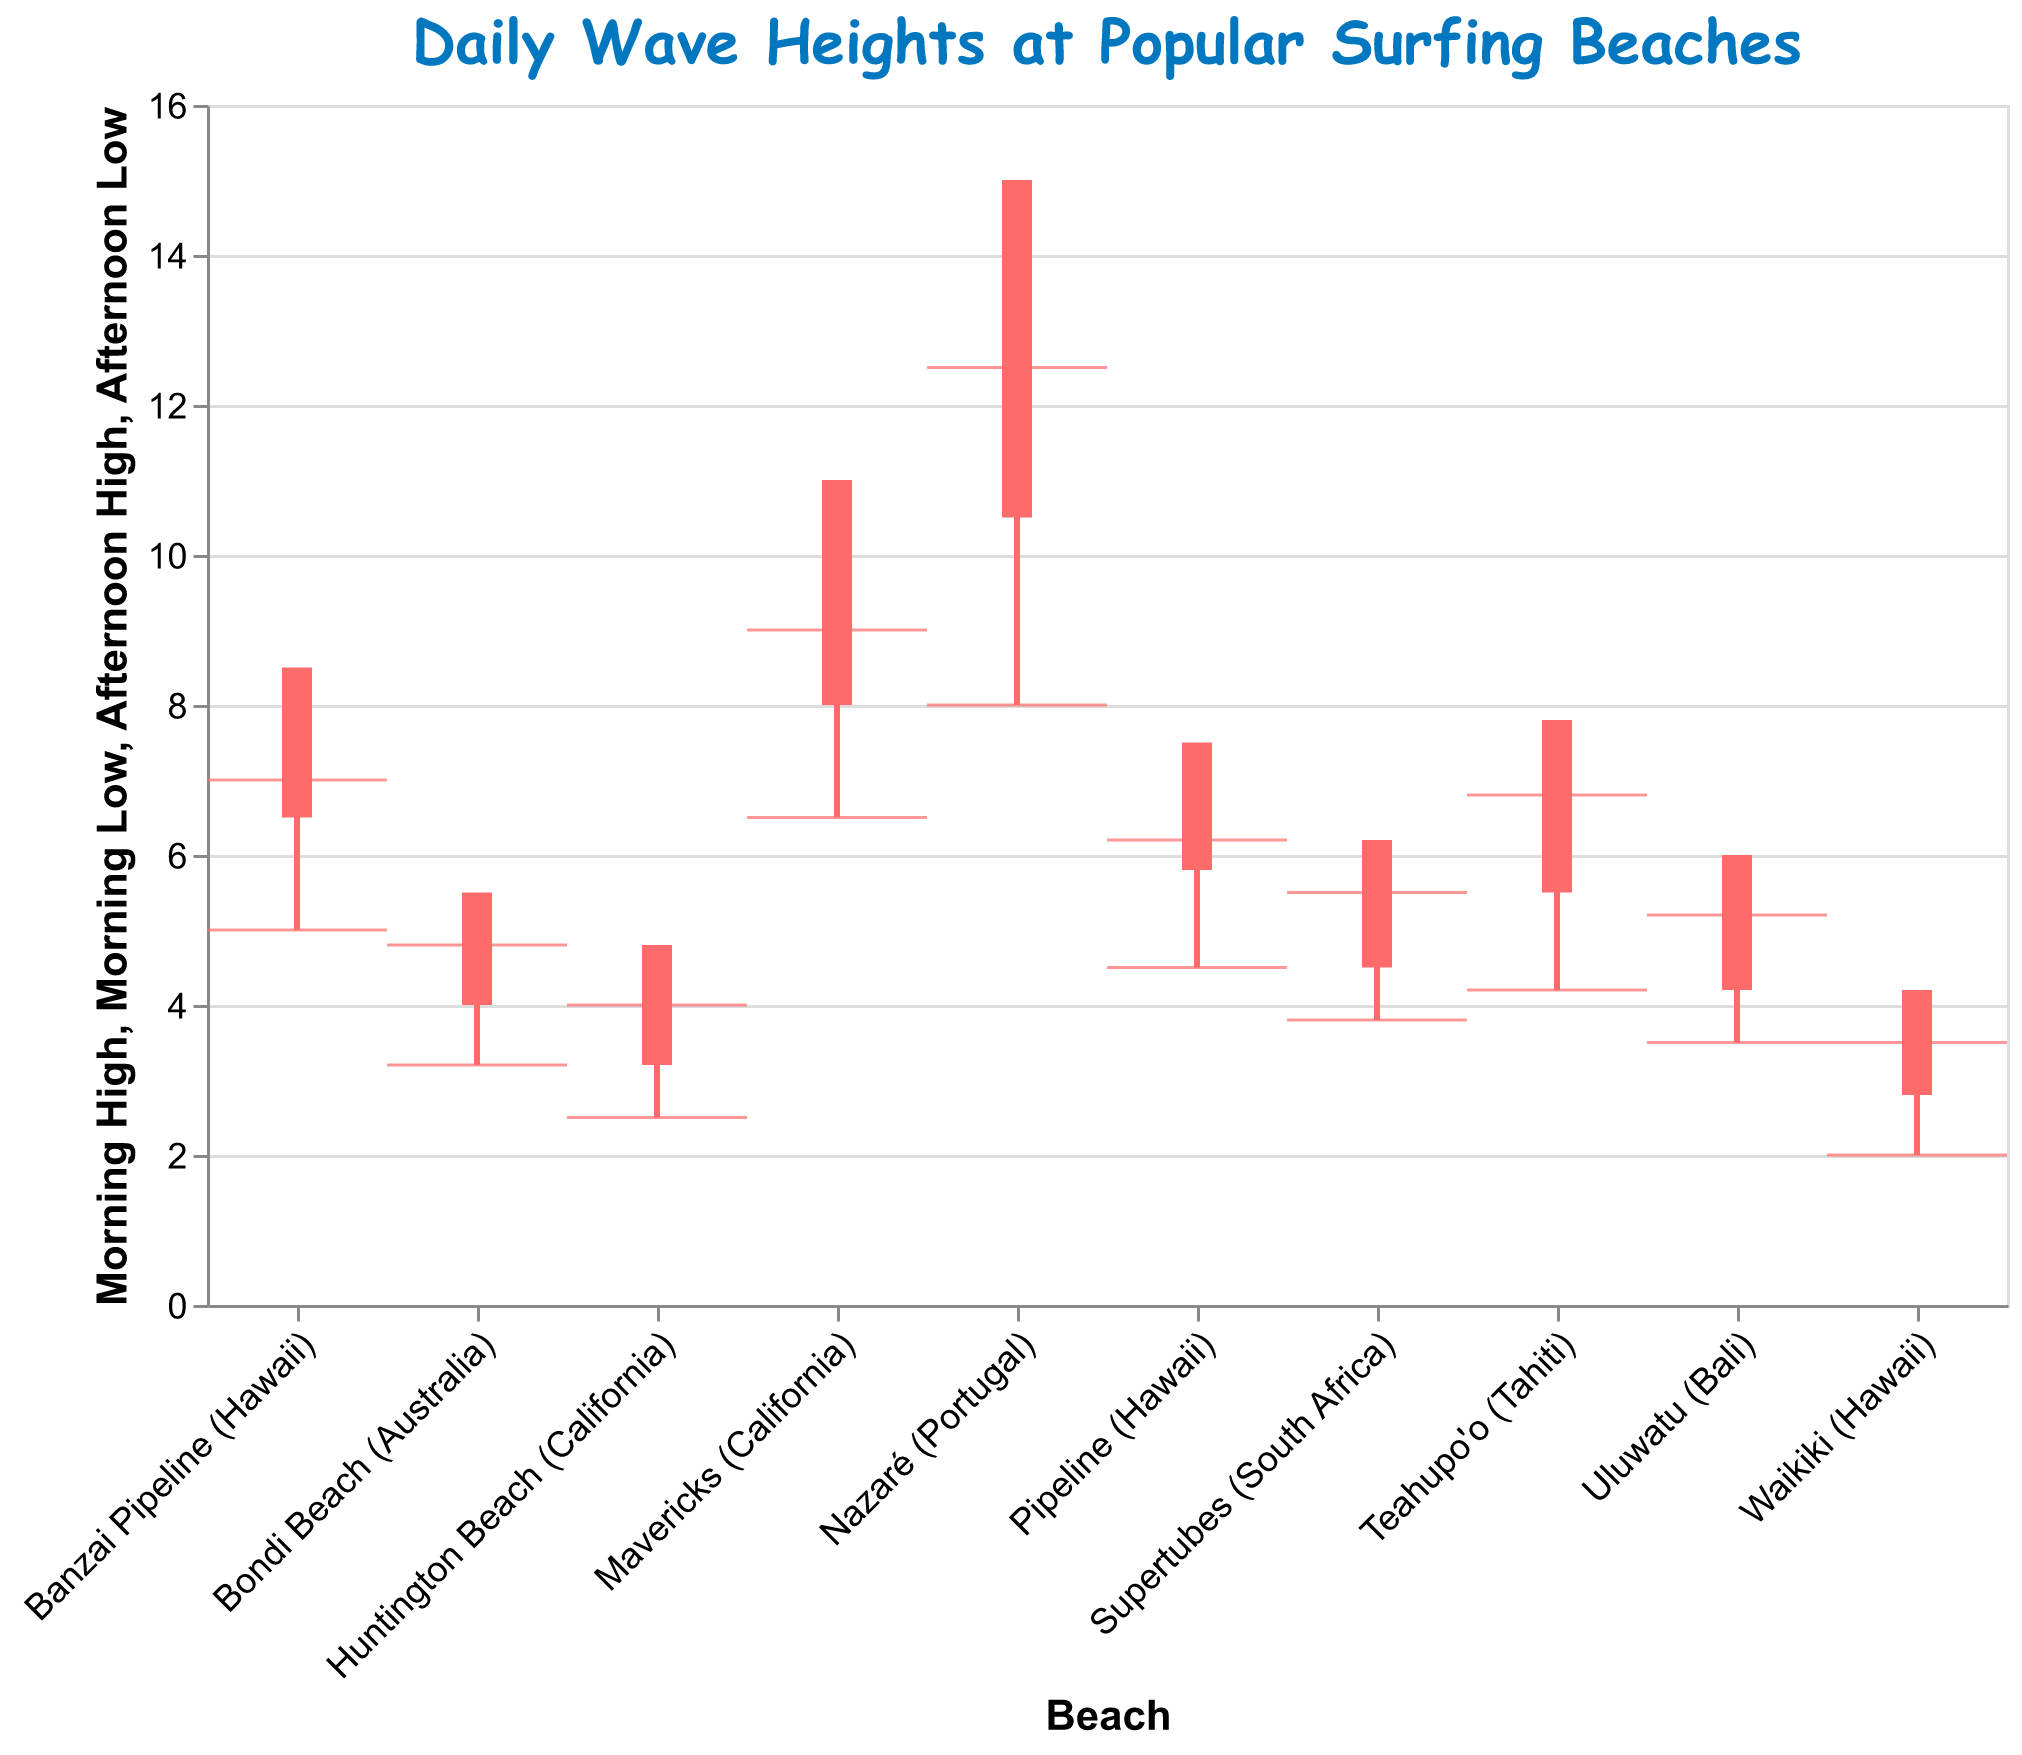How many beaches are shown in the plot? By counting the unique beach names on the x-axis, we find the total number of beaches displayed.
Answer: 10 What's the title of the plot? The title is displayed at the top of the figure.
Answer: Daily Wave Heights at Popular Surfing Beaches Which beach has the highest afternoon wave height on June 1, 2023? Nazaré (Portugal) shows the highest afternoon wave height on June 1, 2023, with an afternoon high of 15.0.
Answer: Nazaré (Portugal) What is the afternoon wave height range at Pipeline (Hawaii) on June 1, 2023? The afternoon wave height range at Pipeline (Hawaii) on June 1, 2023, is determined by subtracting the afternoon low from the afternoon high (7.5 - 5.8).
Answer: 1.7 How much higher is the afternoon high wave at Mavericks (California) compared to the morning high on June 2, 2023? The afternoon high (11.0) minus the morning high (9.0) at Mavericks (California) on June 2, 2023, gives the difference.
Answer: 2.0 Which beach has the smallest difference between morning low and afternoon low on June 1, 2023? Bondi Beach (Australia) has a morning low of 3.2 and an afternoon low of 4.0, making a difference of 0.8. Comparing this to all other beaches on June 1, 2023, it holds the smallest difference.
Answer: Bondi Beach (Australia) What is the total morning high wave height for all beaches on June 1, 2023? Adding the morning highs for all beaches on June 1, 2023: Pipeline (6.2) + Bondi Beach (4.8) + Nazaré (12.5) + Waikiki (3.5) + Huntington Beach (4.0).
Answer: 31.0 Which beach shows the largest increase from morning low to afternoon high on June 2, 2023? To find the largest increase from morning low to afternoon high, we calculate the increase for each beach and compare them. For example, Mavericks (California) has an increase from 6.5 to 11.0, which is 4.5, while other beaches generally show smaller increases.
Answer: Mavericks (California) Is there a beach that has a higher morning low wave height than its afternoon high on June 2, 2023? By comparing the morning low and afternoon high for each beach on June 2, 2023, we see that no morning low is higher than its respective afternoon high.
Answer: No Which beaches have a morning low wave height less than 3.0 on June 1, 2023? By looking at the morning low values for each beach on June 1, 2023, Waikiki (2.0) is the only beach with a morning low wave height less than 3.0.
Answer: Waikiki 